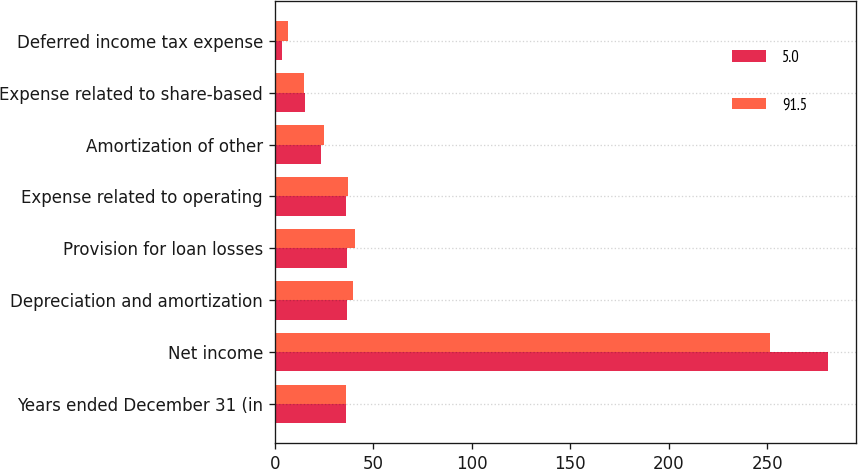Convert chart. <chart><loc_0><loc_0><loc_500><loc_500><stacked_bar_chart><ecel><fcel>Years ended December 31 (in<fcel>Net income<fcel>Depreciation and amortization<fcel>Provision for loan losses<fcel>Expense related to operating<fcel>Amortization of other<fcel>Expense related to share-based<fcel>Deferred income tax expense<nl><fcel>5<fcel>36.45<fcel>281<fcel>36.9<fcel>36.6<fcel>36.3<fcel>23.6<fcel>15.2<fcel>3.7<nl><fcel>91.5<fcel>36.45<fcel>251.7<fcel>39.6<fcel>40.6<fcel>37.4<fcel>24.8<fcel>14.9<fcel>6.7<nl></chart> 